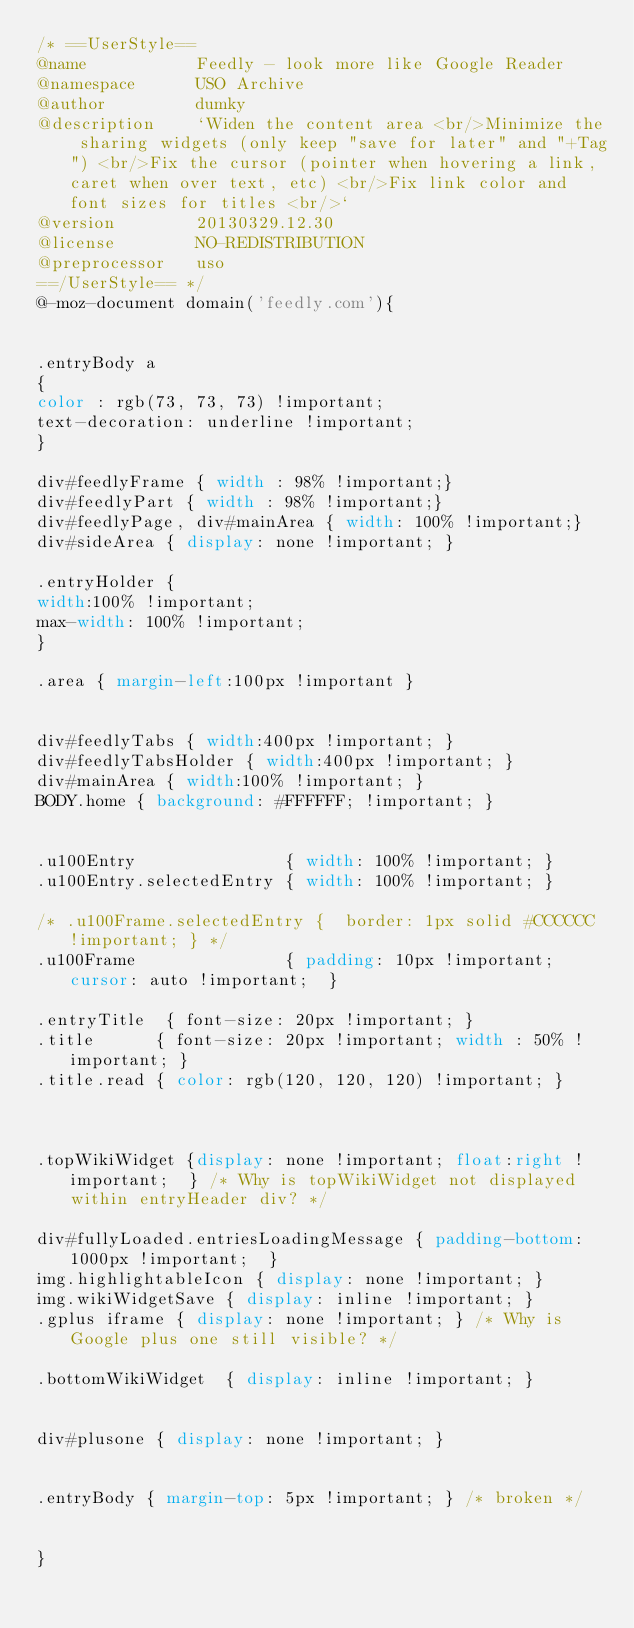Convert code to text. <code><loc_0><loc_0><loc_500><loc_500><_CSS_>/* ==UserStyle==
@name           Feedly - look more like Google Reader
@namespace      USO Archive
@author         dumky
@description    `Widen the content area <br/>Minimize the sharing widgets (only keep "save for later" and "+Tag") <br/>Fix the cursor (pointer when hovering a link, caret when over text, etc) <br/>Fix link color and font sizes for titles <br/>`
@version        20130329.12.30
@license        NO-REDISTRIBUTION
@preprocessor   uso
==/UserStyle== */
@-moz-document domain('feedly.com'){


.entryBody a 
{ 
color : rgb(73, 73, 73) !important;
text-decoration: underline !important;
} 

div#feedlyFrame { width : 98% !important;}
div#feedlyPart { width : 98% !important;}
div#feedlyPage, div#mainArea { width: 100% !important;}
div#sideArea { display: none !important; }

.entryHolder {
width:100% !important;
max-width: 100% !important;
}

.area { margin-left:100px !important } 


div#feedlyTabs { width:400px !important; }
div#feedlyTabsHolder { width:400px !important; }
div#mainArea { width:100% !important; }
BODY.home { background: #FFFFFF; !important; }


.u100Entry               { width: 100% !important; }
.u100Entry.selectedEntry { width: 100% !important; } 

/* .u100Frame.selectedEntry {  border: 1px solid #CCCCCC !important; } */
.u100Frame               { padding: 10px !important; cursor: auto !important;  }

.entryTitle  { font-size: 20px !important; }
.title      { font-size: 20px !important; width : 50% !important; }
.title.read { color: rgb(120, 120, 120) !important; }



.topWikiWidget {display: none !important; float:right !important;  } /* Why is topWikiWidget not displayed within entryHeader div? */

div#fullyLoaded.entriesLoadingMessage { padding-bottom: 1000px !important;  }
img.highlightableIcon { display: none !important; }
img.wikiWidgetSave { display: inline !important; }
.gplus iframe { display: none !important; } /* Why is Google plus one still visible? */

.bottomWikiWidget  { display: inline !important; }


div#plusone { display: none !important; }


.entryBody { margin-top: 5px !important; } /* broken */


}</code> 